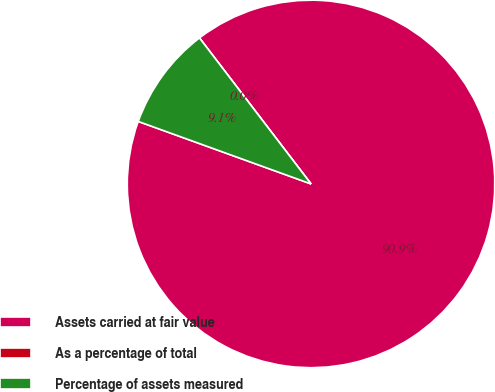Convert chart. <chart><loc_0><loc_0><loc_500><loc_500><pie_chart><fcel>Assets carried at fair value<fcel>As a percentage of total<fcel>Percentage of assets measured<nl><fcel>90.91%<fcel>0.0%<fcel>9.09%<nl></chart> 